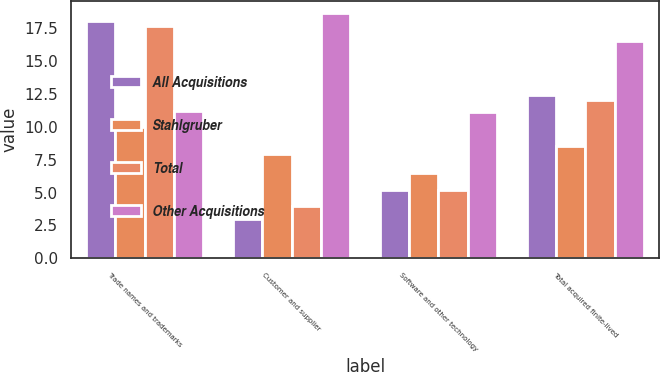Convert chart. <chart><loc_0><loc_0><loc_500><loc_500><stacked_bar_chart><ecel><fcel>Trade names and trademarks<fcel>Customer and supplier<fcel>Software and other technology<fcel>Total acquired finite-lived<nl><fcel>All Acquisitions<fcel>18<fcel>3<fcel>5.2<fcel>12.4<nl><fcel>Stahlgruber<fcel>10<fcel>7.9<fcel>6.5<fcel>8.5<nl><fcel>Total<fcel>17.6<fcel>4<fcel>5.2<fcel>12<nl><fcel>Other Acquisitions<fcel>11.2<fcel>18.6<fcel>11.1<fcel>16.5<nl></chart> 